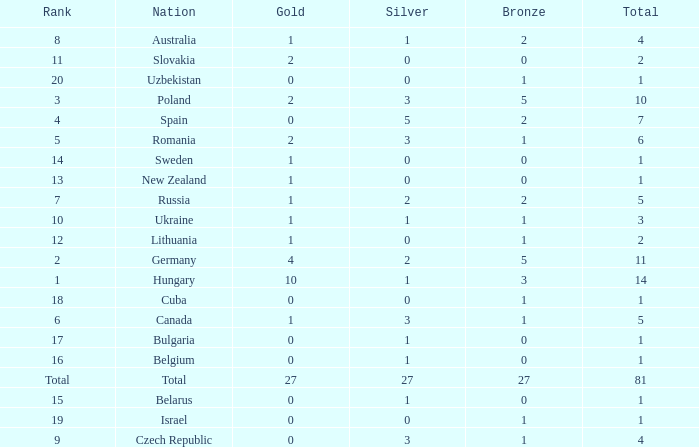Which Rank has a Bronze of 1, and a Nation of lithuania? 12.0. 